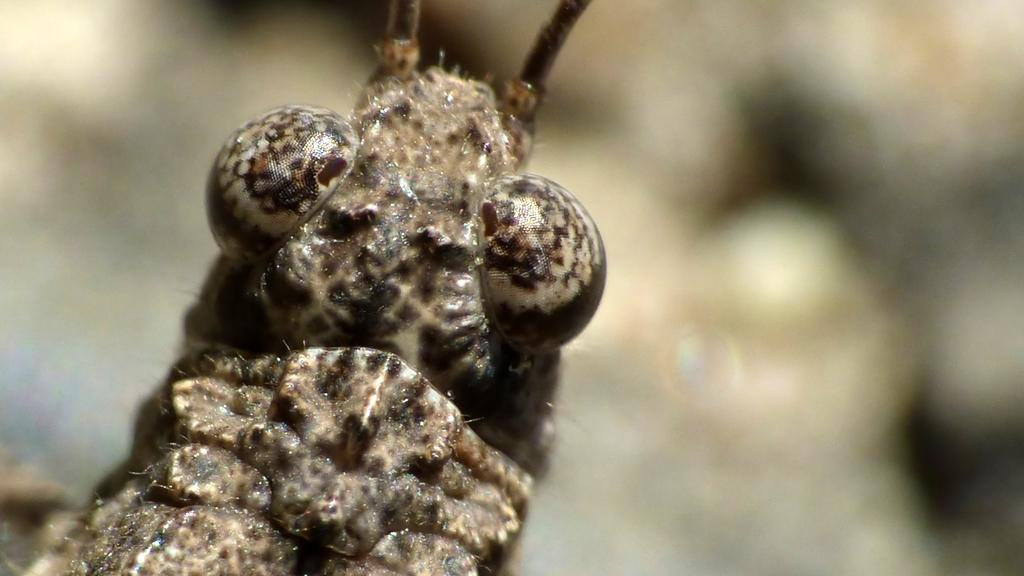What type of creature is in the image? There is an insect in the image. Can you describe the coloring of the insect? The insect has black and brown coloring. What can be observed about the background of the image? The background of the image is blurred. How many rings are visible on the scarecrow in the image? There is no scarecrow or rings present in the image; it features an insect with black and brown coloring against a blurred background. 